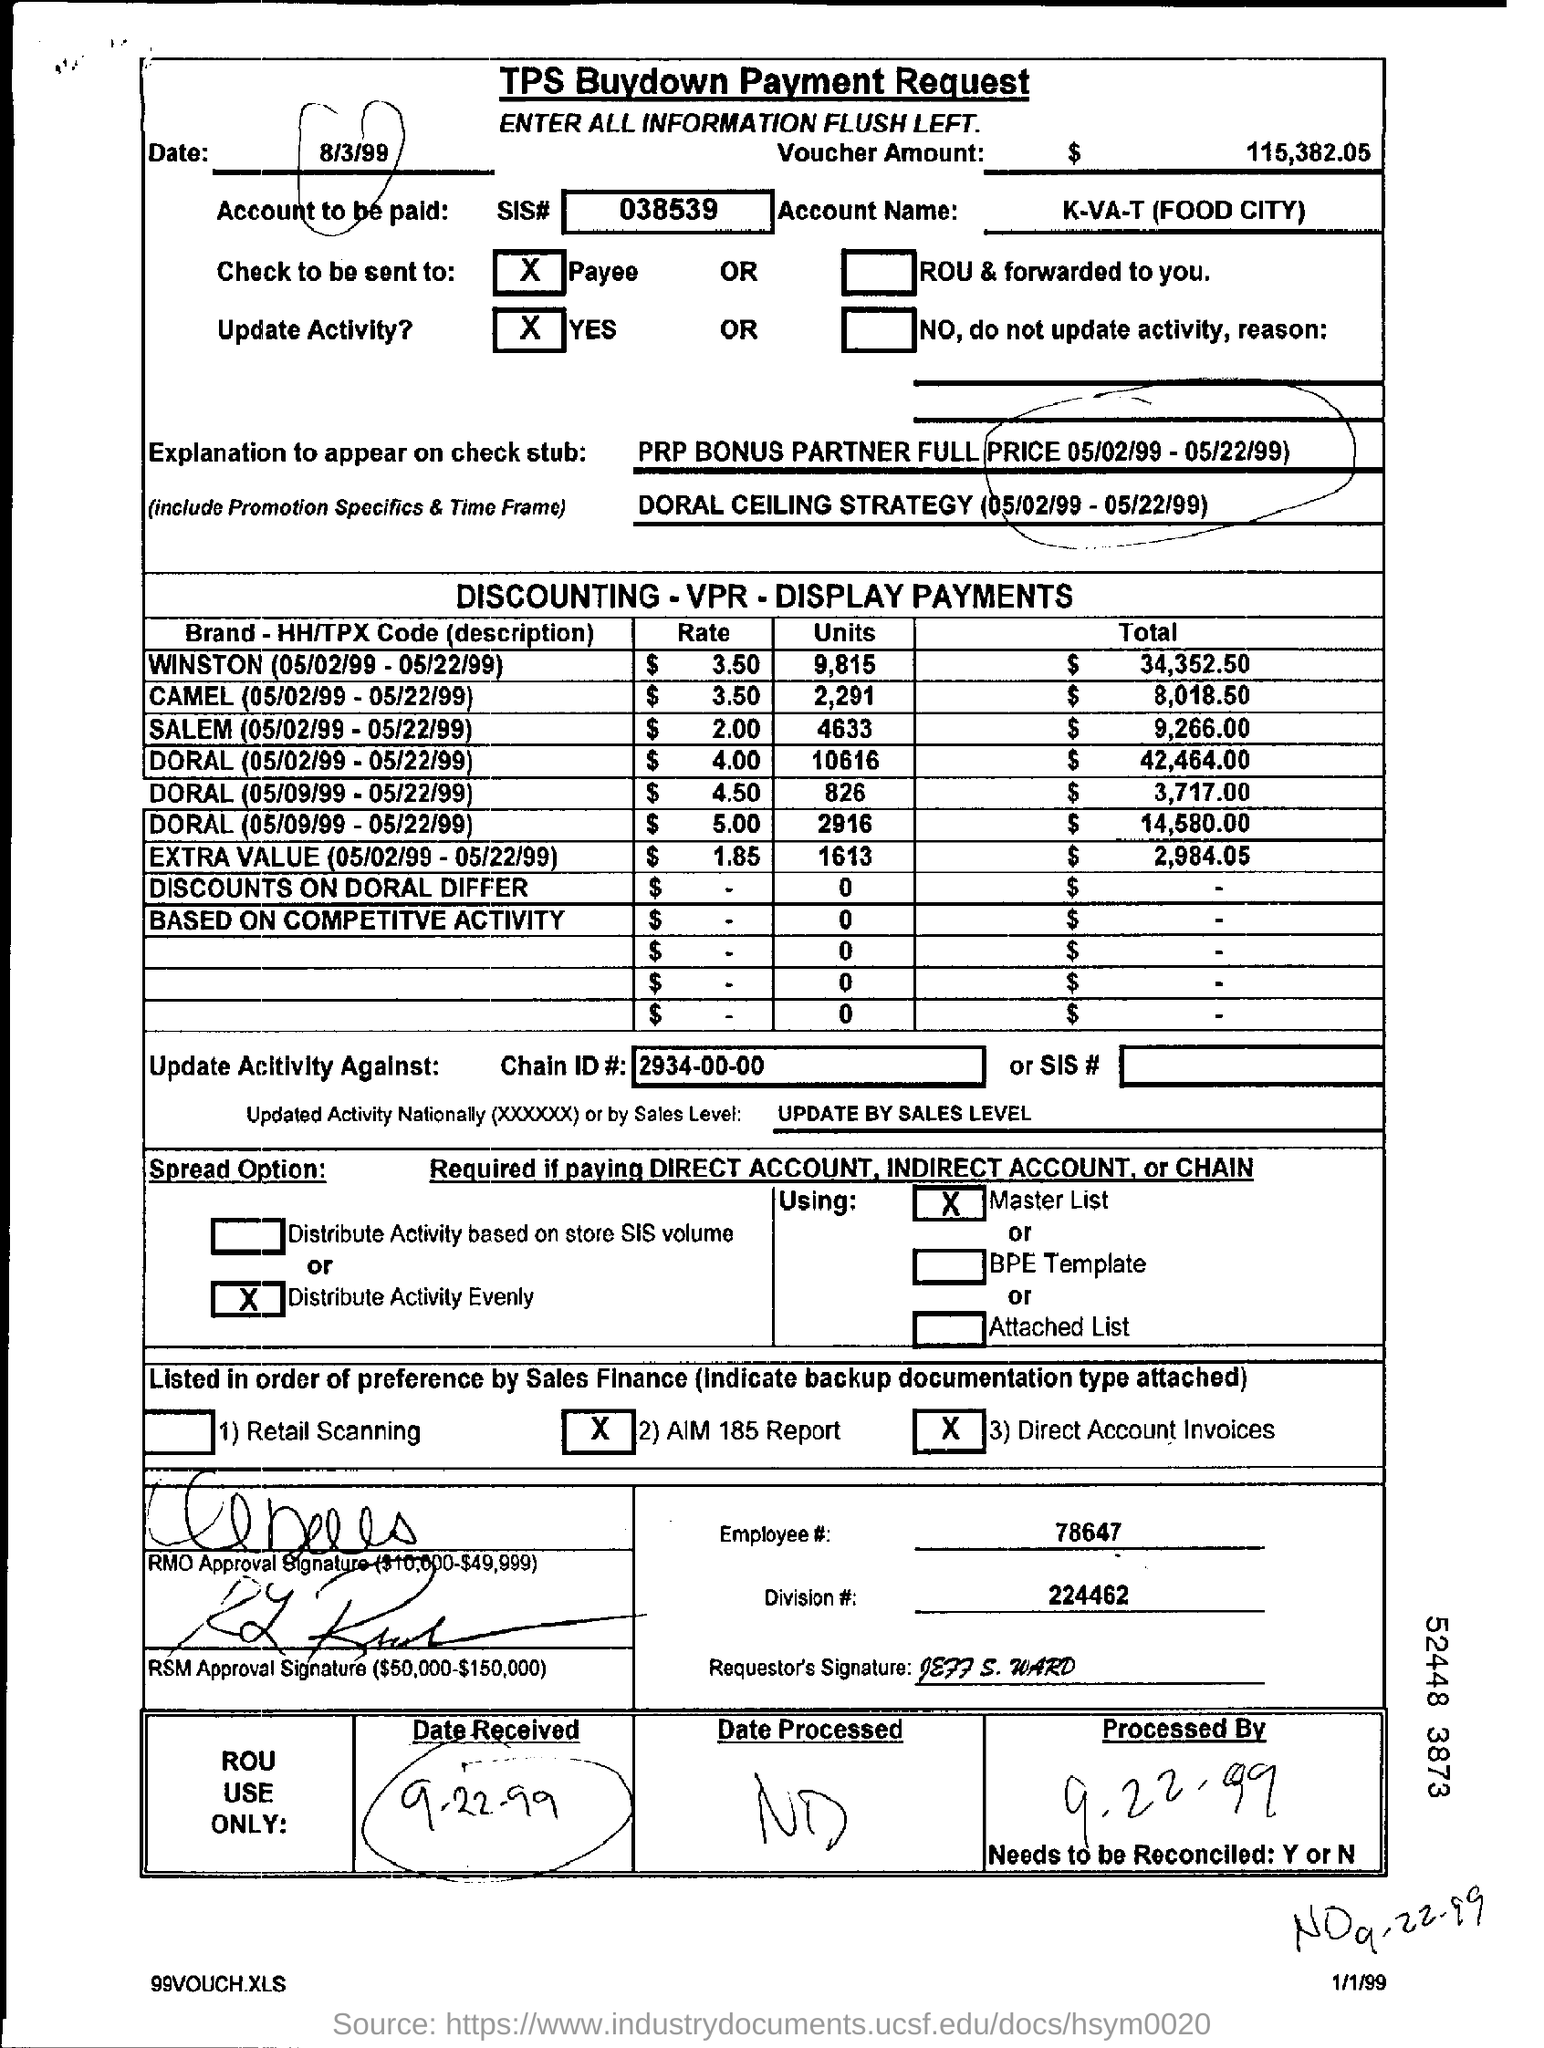What is the date listed at the top of the form, and can you explain its significance? The date listed at the top of the form is 8/3/99, which likely indicates the date when this buydown payment request was created or submitted. Who is the payment going to according to the document? The payment is going to K-VA-T (Food City) as specified in the 'Account Name' field with the SIS# 038539. 